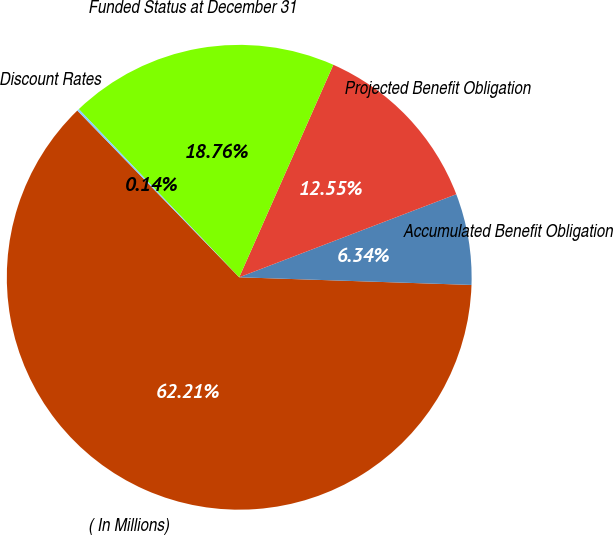Convert chart. <chart><loc_0><loc_0><loc_500><loc_500><pie_chart><fcel>( In Millions)<fcel>Accumulated Benefit Obligation<fcel>Projected Benefit Obligation<fcel>Funded Status at December 31<fcel>Discount Rates<nl><fcel>62.21%<fcel>6.34%<fcel>12.55%<fcel>18.76%<fcel>0.14%<nl></chart> 